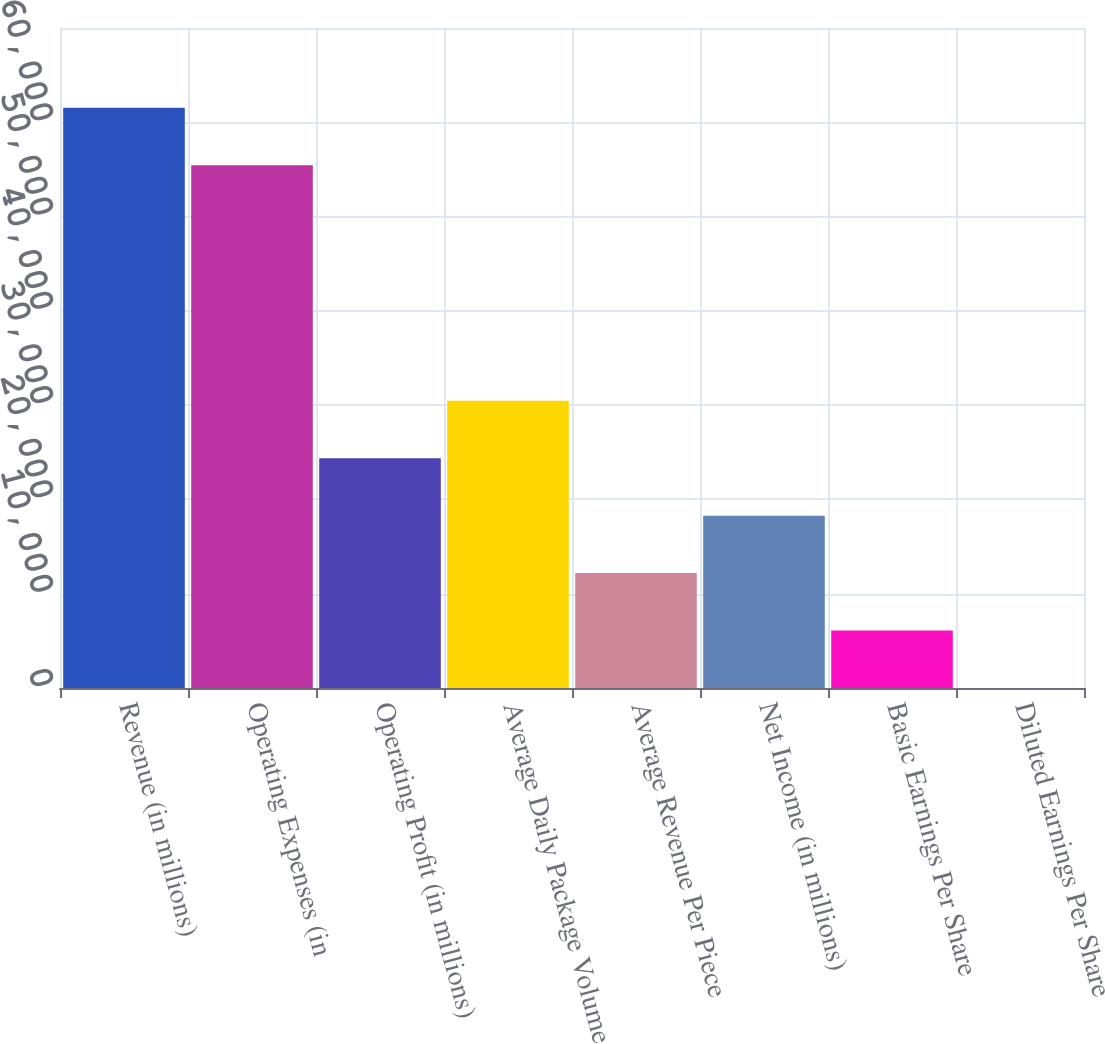Convert chart to OTSL. <chart><loc_0><loc_0><loc_500><loc_500><bar_chart><fcel>Revenue (in millions)<fcel>Operating Expenses (in<fcel>Operating Profit (in millions)<fcel>Average Daily Package Volume<fcel>Average Revenue Per Piece<fcel>Net Income (in millions)<fcel>Basic Earnings Per Share<fcel>Diluted Earnings Per Share<nl><fcel>61529.2<fcel>55439<fcel>24364.7<fcel>30454.9<fcel>12184.3<fcel>18274.5<fcel>6094.08<fcel>3.87<nl></chart> 